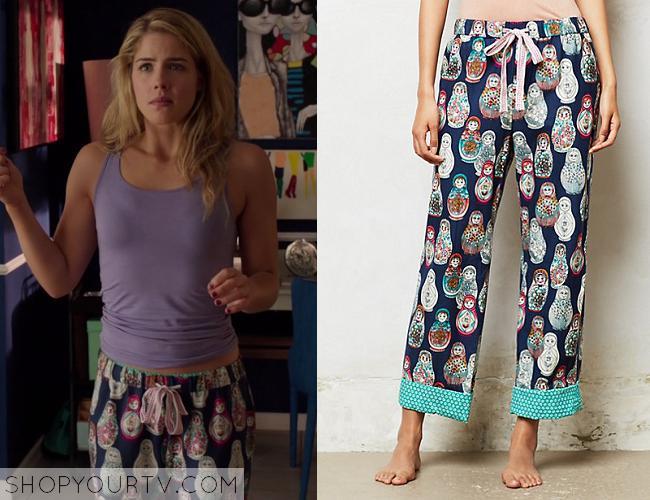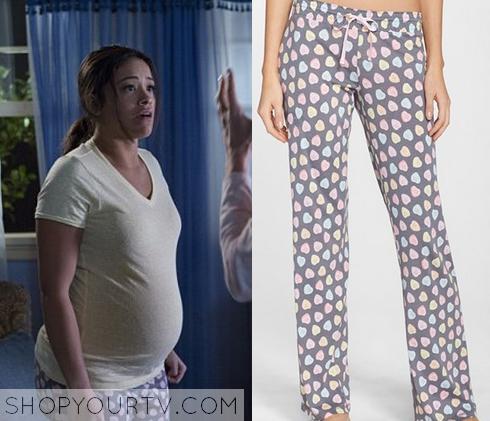The first image is the image on the left, the second image is the image on the right. Given the left and right images, does the statement "There is at least 1 person facing right in the right image." hold true? Answer yes or no. Yes. 